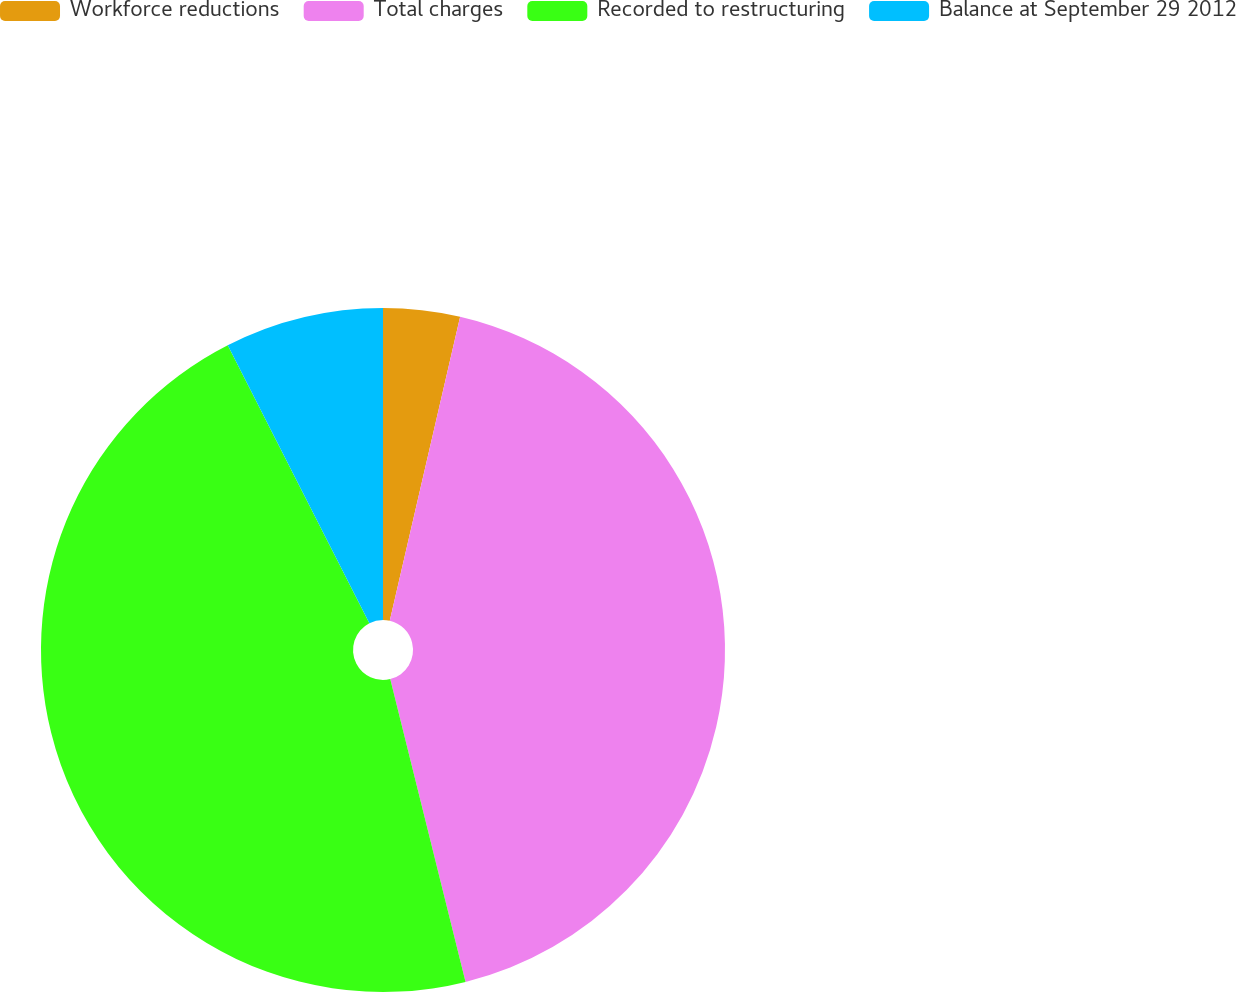<chart> <loc_0><loc_0><loc_500><loc_500><pie_chart><fcel>Workforce reductions<fcel>Total charges<fcel>Recorded to restructuring<fcel>Balance at September 29 2012<nl><fcel>3.62%<fcel>42.5%<fcel>46.38%<fcel>7.5%<nl></chart> 